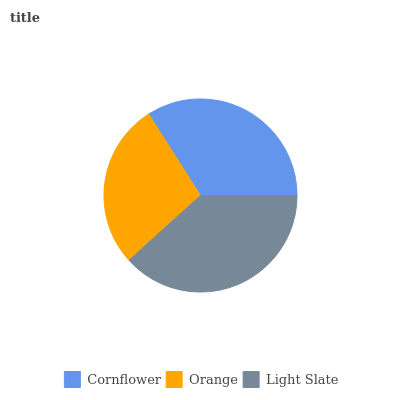Is Orange the minimum?
Answer yes or no. Yes. Is Light Slate the maximum?
Answer yes or no. Yes. Is Light Slate the minimum?
Answer yes or no. No. Is Orange the maximum?
Answer yes or no. No. Is Light Slate greater than Orange?
Answer yes or no. Yes. Is Orange less than Light Slate?
Answer yes or no. Yes. Is Orange greater than Light Slate?
Answer yes or no. No. Is Light Slate less than Orange?
Answer yes or no. No. Is Cornflower the high median?
Answer yes or no. Yes. Is Cornflower the low median?
Answer yes or no. Yes. Is Light Slate the high median?
Answer yes or no. No. Is Orange the low median?
Answer yes or no. No. 